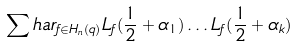<formula> <loc_0><loc_0><loc_500><loc_500>\sum h a r _ { f \in H _ { n } ( q ) } L _ { f } ( \frac { 1 } { 2 } + \alpha _ { 1 } ) \dots L _ { f } ( \frac { 1 } { 2 } + \alpha _ { k } )</formula> 